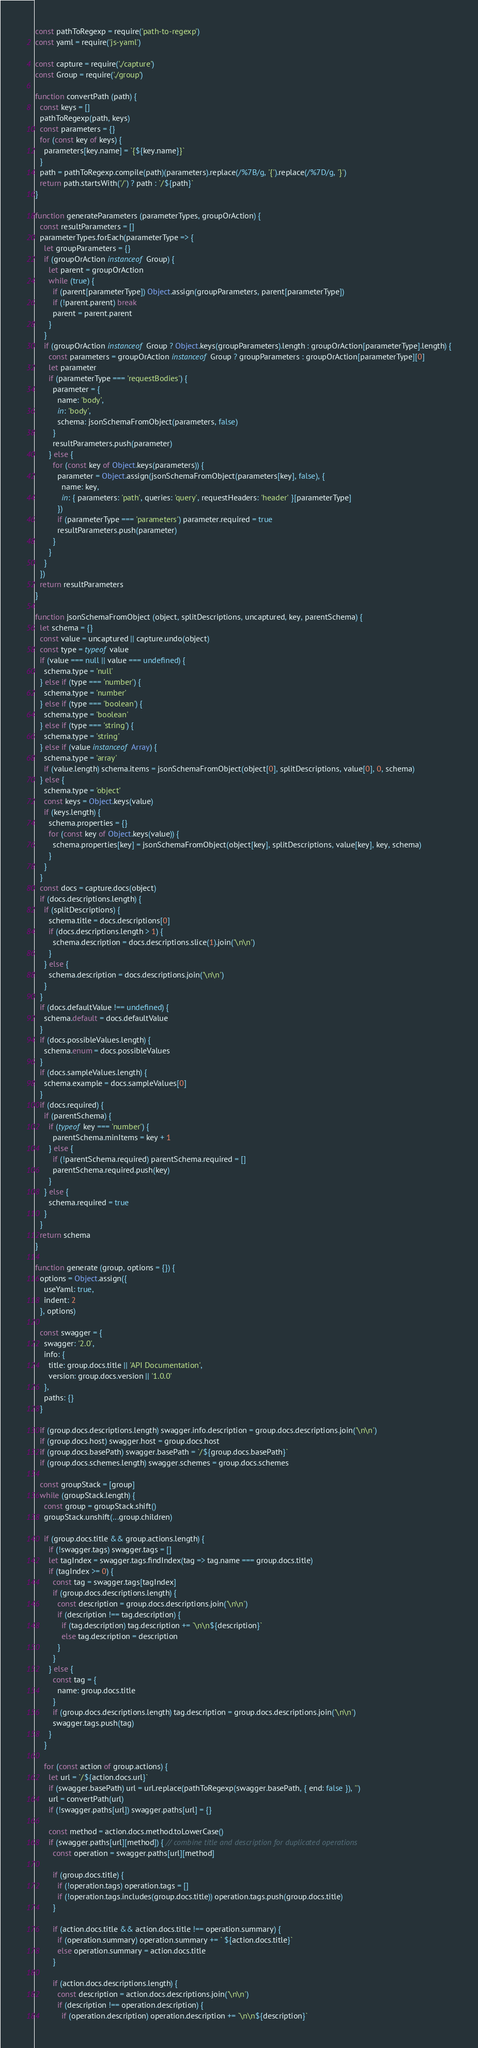<code> <loc_0><loc_0><loc_500><loc_500><_JavaScript_>const pathToRegexp = require('path-to-regexp')
const yaml = require('js-yaml')

const capture = require('./capture')
const Group = require('./group')

function convertPath (path) {
  const keys = []
  pathToRegexp(path, keys)
  const parameters = {}
  for (const key of keys) {
    parameters[key.name] = `{${key.name}}`
  }
  path = pathToRegexp.compile(path)(parameters).replace(/%7B/g, '{').replace(/%7D/g, '}')
  return path.startsWith('/') ? path : `/${path}`
}

function generateParameters (parameterTypes, groupOrAction) {
  const resultParameters = []
  parameterTypes.forEach(parameterType => {
    let groupParameters = {}
    if (groupOrAction instanceof Group) {
      let parent = groupOrAction
      while (true) {
        if (parent[parameterType]) Object.assign(groupParameters, parent[parameterType])
        if (!parent.parent) break
        parent = parent.parent
      }
    }
    if (groupOrAction instanceof Group ? Object.keys(groupParameters).length : groupOrAction[parameterType].length) {
      const parameters = groupOrAction instanceof Group ? groupParameters : groupOrAction[parameterType][0]
      let parameter
      if (parameterType === 'requestBodies') {
        parameter = {
          name: 'body',
          in: 'body',
          schema: jsonSchemaFromObject(parameters, false)
        }
        resultParameters.push(parameter)
      } else {
        for (const key of Object.keys(parameters)) {
          parameter = Object.assign(jsonSchemaFromObject(parameters[key], false), {
            name: key,
            in: { parameters: 'path', queries: 'query', requestHeaders: 'header' }[parameterType]
          })
          if (parameterType === 'parameters') parameter.required = true
          resultParameters.push(parameter)
        }
      }
    }
  })
  return resultParameters
}

function jsonSchemaFromObject (object, splitDescriptions, uncaptured, key, parentSchema) {
  let schema = {}
  const value = uncaptured || capture.undo(object)
  const type = typeof value
  if (value === null || value === undefined) {
    schema.type = 'null'
  } else if (type === 'number') {
    schema.type = 'number'
  } else if (type === 'boolean') {
    schema.type = 'boolean'
  } else if (type === 'string') {
    schema.type = 'string'
  } else if (value instanceof Array) {
    schema.type = 'array'
    if (value.length) schema.items = jsonSchemaFromObject(object[0], splitDescriptions, value[0], 0, schema)
  } else {
    schema.type = 'object'
    const keys = Object.keys(value)
    if (keys.length) {
      schema.properties = {}
      for (const key of Object.keys(value)) {
        schema.properties[key] = jsonSchemaFromObject(object[key], splitDescriptions, value[key], key, schema)
      }
    }
  }
  const docs = capture.docs(object)
  if (docs.descriptions.length) {
    if (splitDescriptions) {
      schema.title = docs.descriptions[0]
      if (docs.descriptions.length > 1) {
        schema.description = docs.descriptions.slice(1).join('\n\n')
      }
    } else {
      schema.description = docs.descriptions.join('\n\n')
    }
  }
  if (docs.defaultValue !== undefined) {
    schema.default = docs.defaultValue
  }
  if (docs.possibleValues.length) {
    schema.enum = docs.possibleValues
  }
  if (docs.sampleValues.length) {
    schema.example = docs.sampleValues[0]
  }
  if (docs.required) {
    if (parentSchema) {
      if (typeof key === 'number') {
        parentSchema.minItems = key + 1
      } else {
        if (!parentSchema.required) parentSchema.required = []
        parentSchema.required.push(key)
      }
    } else {
      schema.required = true
    }
  }
  return schema
}

function generate (group, options = {}) {
  options = Object.assign({
    useYaml: true,
    indent: 2
  }, options)

  const swagger = {
    swagger: '2.0',
    info: {
      title: group.docs.title || 'API Documentation',
      version: group.docs.version || '1.0.0'
    },
    paths: {}
  }

  if (group.docs.descriptions.length) swagger.info.description = group.docs.descriptions.join('\n\n')
  if (group.docs.host) swagger.host = group.docs.host
  if (group.docs.basePath) swagger.basePath = `/${group.docs.basePath}`
  if (group.docs.schemes.length) swagger.schemes = group.docs.schemes

  const groupStack = [group]
  while (groupStack.length) {
    const group = groupStack.shift()
    groupStack.unshift(...group.children)

    if (group.docs.title && group.actions.length) {
      if (!swagger.tags) swagger.tags = []
      let tagIndex = swagger.tags.findIndex(tag => tag.name === group.docs.title)
      if (tagIndex >= 0) {
        const tag = swagger.tags[tagIndex]
        if (group.docs.descriptions.length) {
          const description = group.docs.descriptions.join('\n\n')
          if (description !== tag.description) {
            if (tag.description) tag.description += `\n\n${description}`
            else tag.description = description
          }
        }
      } else {
        const tag = {
          name: group.docs.title
        }
        if (group.docs.descriptions.length) tag.description = group.docs.descriptions.join('\n\n')
        swagger.tags.push(tag)
      }
    }

    for (const action of group.actions) {
      let url = `/${action.docs.url}`
      if (swagger.basePath) url = url.replace(pathToRegexp(swagger.basePath, { end: false }), '')
      url = convertPath(url)
      if (!swagger.paths[url]) swagger.paths[url] = {}

      const method = action.docs.method.toLowerCase()
      if (swagger.paths[url][method]) { // combine title and description for duplicated operations
        const operation = swagger.paths[url][method]

        if (group.docs.title) {
          if (!operation.tags) operation.tags = []
          if (!operation.tags.includes(group.docs.title)) operation.tags.push(group.docs.title)
        }

        if (action.docs.title && action.docs.title !== operation.summary) {
          if (operation.summary) operation.summary += ` ${action.docs.title}`
          else operation.summary = action.docs.title
        }

        if (action.docs.descriptions.length) {
          const description = action.docs.descriptions.join('\n\n')
          if (description !== operation.description) {
            if (operation.description) operation.description += `\n\n${description}`</code> 